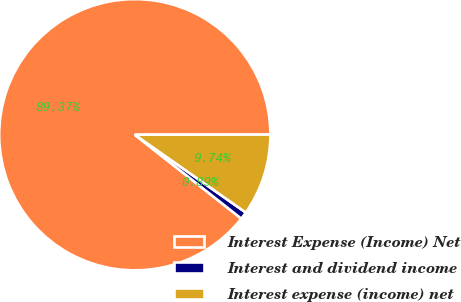<chart> <loc_0><loc_0><loc_500><loc_500><pie_chart><fcel>Interest Expense (Income) Net<fcel>Interest and dividend income<fcel>Interest expense (income) net<nl><fcel>89.37%<fcel>0.89%<fcel>9.74%<nl></chart> 